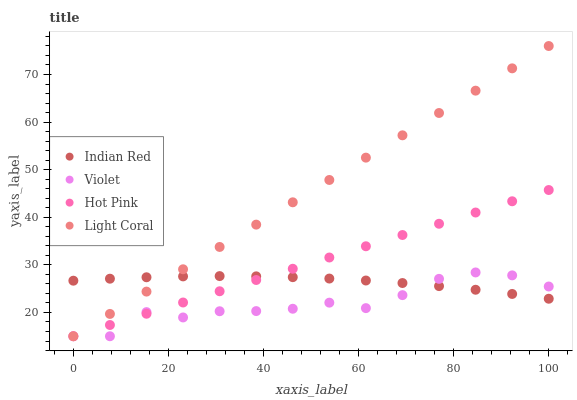Does Violet have the minimum area under the curve?
Answer yes or no. Yes. Does Light Coral have the maximum area under the curve?
Answer yes or no. Yes. Does Hot Pink have the minimum area under the curve?
Answer yes or no. No. Does Hot Pink have the maximum area under the curve?
Answer yes or no. No. Is Hot Pink the smoothest?
Answer yes or no. Yes. Is Violet the roughest?
Answer yes or no. Yes. Is Indian Red the smoothest?
Answer yes or no. No. Is Indian Red the roughest?
Answer yes or no. No. Does Light Coral have the lowest value?
Answer yes or no. Yes. Does Indian Red have the lowest value?
Answer yes or no. No. Does Light Coral have the highest value?
Answer yes or no. Yes. Does Hot Pink have the highest value?
Answer yes or no. No. Does Violet intersect Hot Pink?
Answer yes or no. Yes. Is Violet less than Hot Pink?
Answer yes or no. No. Is Violet greater than Hot Pink?
Answer yes or no. No. 